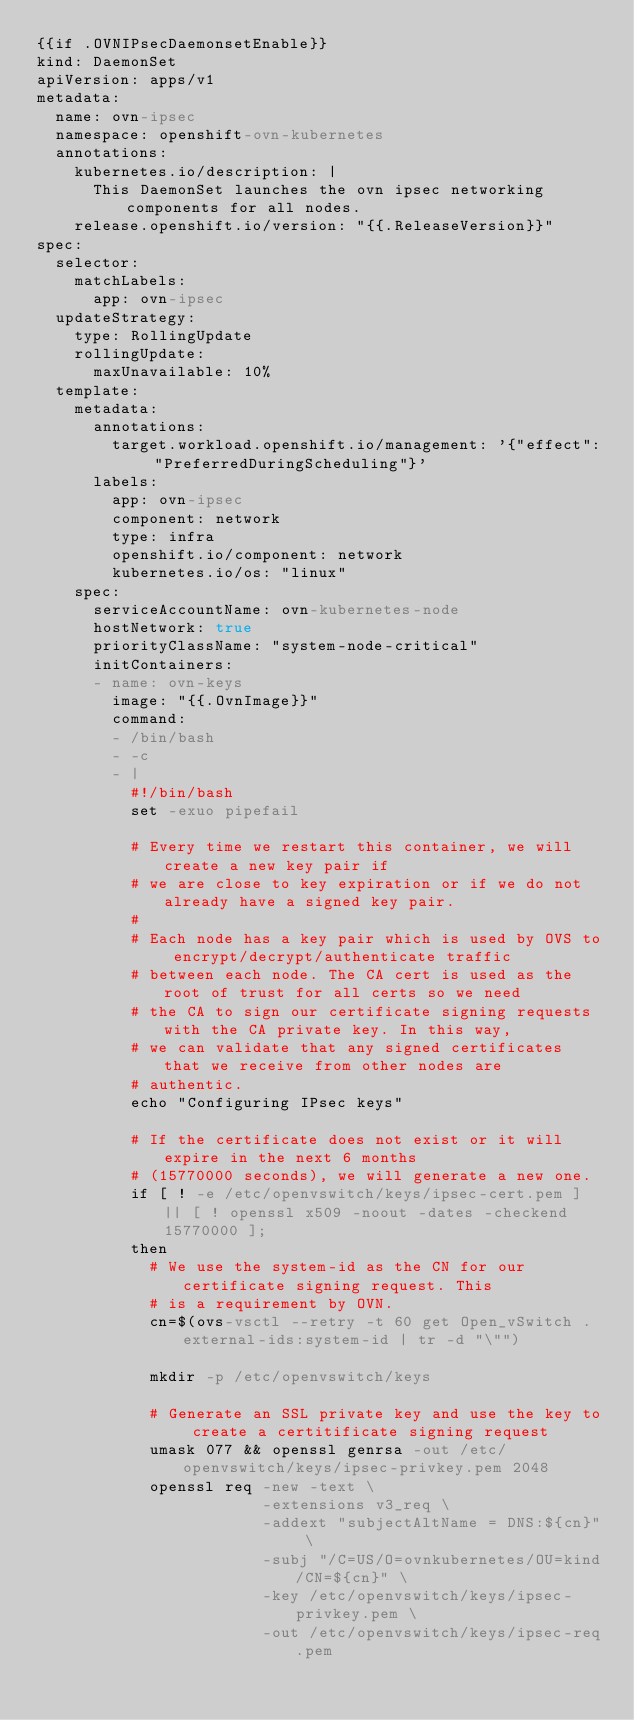<code> <loc_0><loc_0><loc_500><loc_500><_YAML_>{{if .OVNIPsecDaemonsetEnable}}
kind: DaemonSet
apiVersion: apps/v1
metadata:
  name: ovn-ipsec
  namespace: openshift-ovn-kubernetes
  annotations:
    kubernetes.io/description: |
      This DaemonSet launches the ovn ipsec networking components for all nodes.
    release.openshift.io/version: "{{.ReleaseVersion}}"
spec:
  selector:
    matchLabels:
      app: ovn-ipsec
  updateStrategy:
    type: RollingUpdate
    rollingUpdate:
      maxUnavailable: 10%
  template:
    metadata:
      annotations:
        target.workload.openshift.io/management: '{"effect": "PreferredDuringScheduling"}'
      labels:
        app: ovn-ipsec
        component: network
        type: infra
        openshift.io/component: network
        kubernetes.io/os: "linux"
    spec:
      serviceAccountName: ovn-kubernetes-node
      hostNetwork: true
      priorityClassName: "system-node-critical"
      initContainers:
      - name: ovn-keys
        image: "{{.OvnImage}}"
        command:
        - /bin/bash
        - -c
        - |
          #!/bin/bash
          set -exuo pipefail

          # Every time we restart this container, we will create a new key pair if
          # we are close to key expiration or if we do not already have a signed key pair.
          #
          # Each node has a key pair which is used by OVS to encrypt/decrypt/authenticate traffic
          # between each node. The CA cert is used as the root of trust for all certs so we need
          # the CA to sign our certificate signing requests with the CA private key. In this way,
          # we can validate that any signed certificates that we receive from other nodes are
          # authentic.
          echo "Configuring IPsec keys"

          # If the certificate does not exist or it will expire in the next 6 months
          # (15770000 seconds), we will generate a new one.
          if [ ! -e /etc/openvswitch/keys/ipsec-cert.pem ] || [ ! openssl x509 -noout -dates -checkend 15770000 ];
          then
            # We use the system-id as the CN for our certificate signing request. This
            # is a requirement by OVN.
            cn=$(ovs-vsctl --retry -t 60 get Open_vSwitch . external-ids:system-id | tr -d "\"")

            mkdir -p /etc/openvswitch/keys

            # Generate an SSL private key and use the key to create a certitificate signing request
            umask 077 && openssl genrsa -out /etc/openvswitch/keys/ipsec-privkey.pem 2048
            openssl req -new -text \
                        -extensions v3_req \
                        -addext "subjectAltName = DNS:${cn}" \
                        -subj "/C=US/O=ovnkubernetes/OU=kind/CN=${cn}" \
                        -key /etc/openvswitch/keys/ipsec-privkey.pem \
                        -out /etc/openvswitch/keys/ipsec-req.pem
</code> 